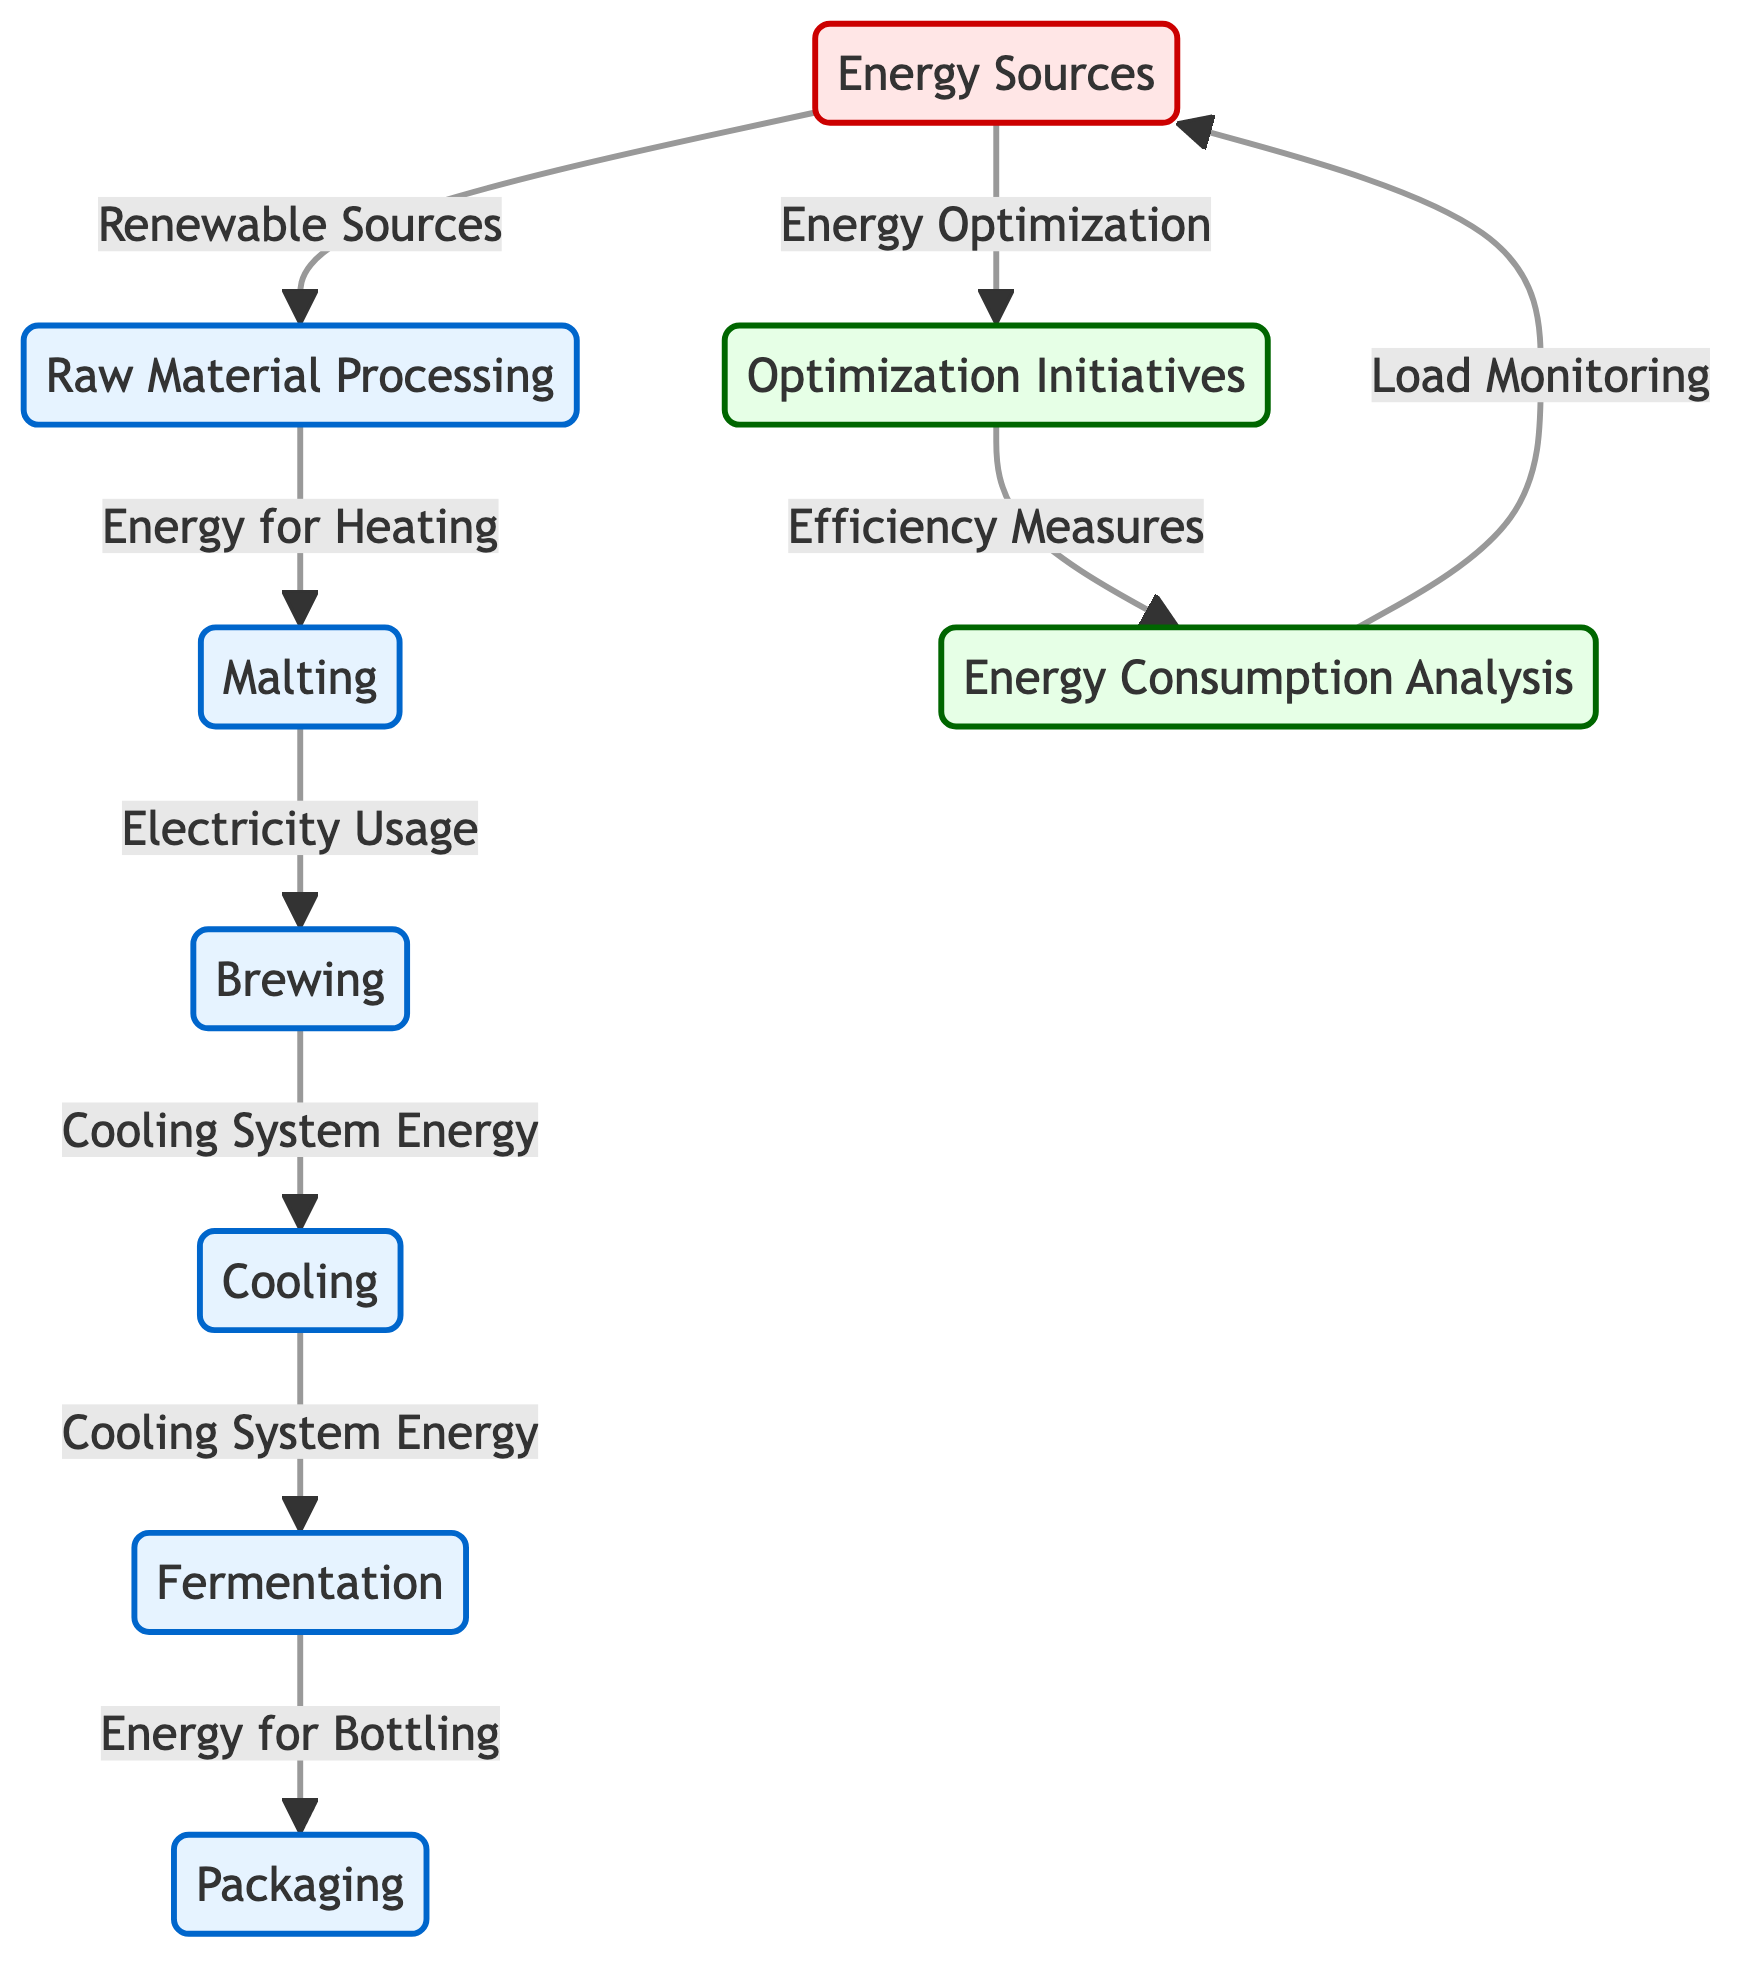What is the first process in the energy usage analysis? The first process node in the diagram is "Raw Material Processing," which is connected to the "Malting" process, indicating that it is the starting point.
Answer: Raw Material Processing How many main processes are depicted in the diagram? By counting the process nodes, there are six main processes: Raw Material Processing, Malting, Brewing, Cooling, Fermentation, and Packaging.
Answer: Six What type of energy is used for Heating in the brewery? The diagram specifies that "Energy for Heating" is directed from the "Raw Material Processing" node to the "Malting" node, indicating the type of energy used for this purpose.
Answer: Energy for Heating Which process is associated with "Cooling System Energy"? There are two connections to the "Cooling System Energy" label: it flows from "Brewing" to "Cooling," and then from "Cooling" to "Fermentation," indicating that both brewing and cooling processes utilize this energy.
Answer: Brewing and Cooling What does the "Energy Consumption Analysis" node analyze? The "Energy Consumption Analysis" node focuses on "Load Monitoring," which signifies that it evaluates energy usage patterns based on load data, linking it to the sources of energy utilized.
Answer: Load Monitoring What initiative is linked to energy optimization in the brewery? The energy optimization initiative is detailed in the node labeled "Optimization Initiatives," which is linked to both "Energy Sources" and "Energy Consumption Analysis," indicating a focus on improving efficiency.
Answer: Optimization Initiatives How is renewable energy integrated into the brewing process? "Renewable Sources" flow into the "Raw Materials" node, indicating that renewable energy is utilized right from the start of the brewing process, promoting sustainable practices.
Answer: Renewable Sources Which process comes after fermentation in the diagram? The diagram shows that the process that follows "Fermentation" is "Packaging," indicating the sequence of steps in the brewing process.
Answer: Packaging What is the purpose of the "Optimization Initiatives" node? The "Optimization Initiatives" node serves to enhance energy efficiency in the brewery processes, as it links directly to "Energy Consumption Analysis" with an emphasis on "Efficiency Measures."
Answer: Enhance efficiency 